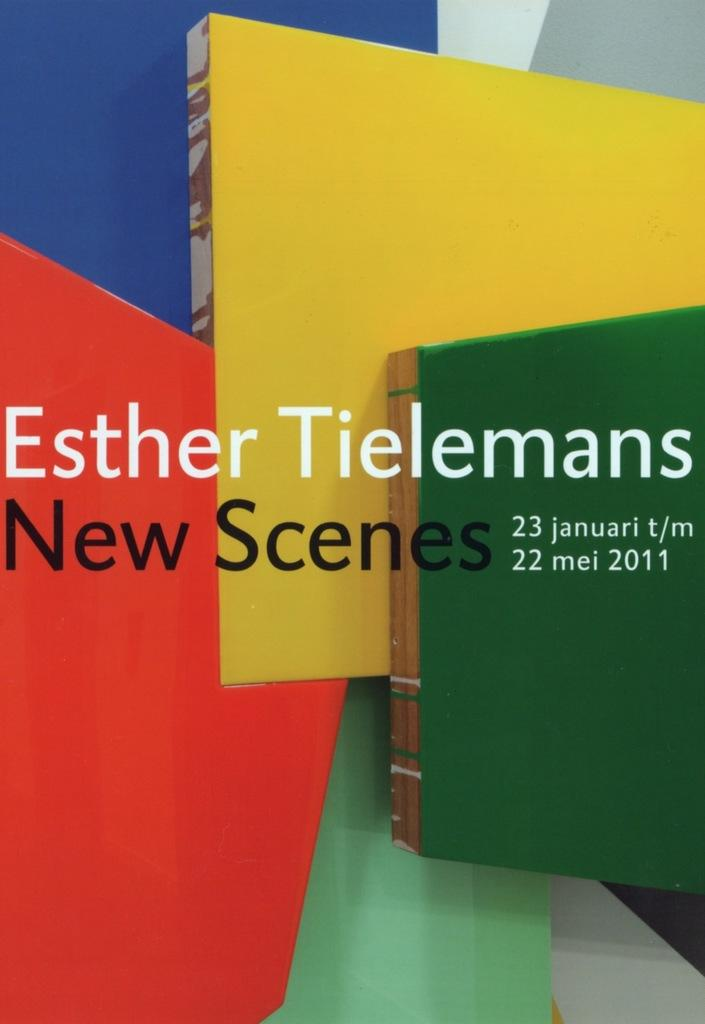<image>
Give a short and clear explanation of the subsequent image. The book by Ester Tielmans Is called New Scenes. 